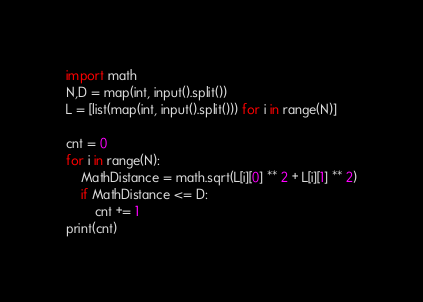<code> <loc_0><loc_0><loc_500><loc_500><_Python_>import math
N,D = map(int, input().split())
L = [list(map(int, input().split())) for i in range(N)]

cnt = 0
for i in range(N):
    MathDistance = math.sqrt(L[i][0] ** 2 + L[i][1] ** 2)
    if MathDistance <= D:
        cnt += 1
print(cnt)</code> 